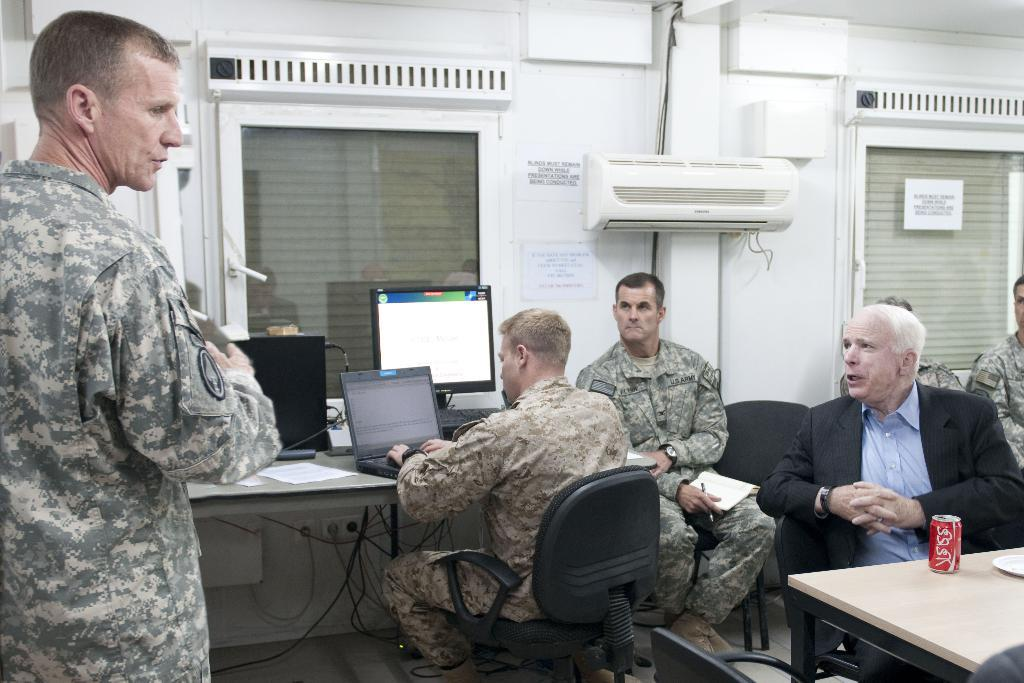What is the position of the man in the image? There is a man standing at the right side of the image. What are the other people in the image doing? The other people are sitting in the image. Can you describe the activity of the man in the background? There is a man working on a laptop in the background. What can be seen through the window in the image? The window is visible in the image, but the view through it is not described in the facts. What type of structure is visible in the image? There is a wall visible in the image. What type of straw is being used to stir the substance in the image? There is no straw or substance present in the image. 